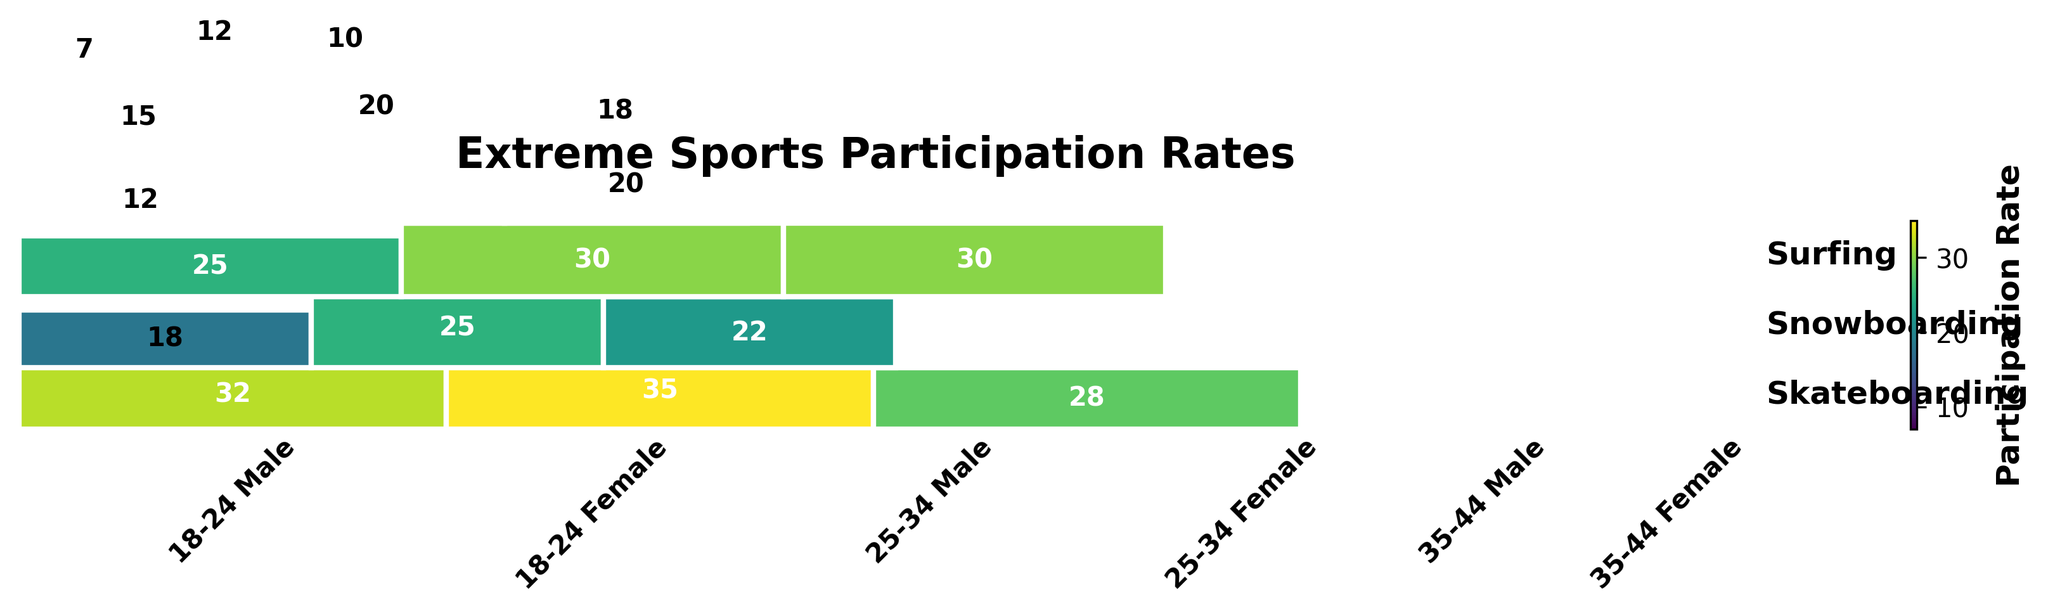Which age group and gender has the highest participation rate in skateboarding? By visually inspecting the plot, look for the rectangle representing the 18-24 age group and male gender under skateboarding. Compare this with other rectangles representing participation in skateboarding to identify which is the largest.
Answer: 18-24 Male What is the combined participation rate for 35-44 years old in all sports? Sum up the values for the 35-44 age group for both Male and Female across all sports. Add 15 (Skateboarding), 7 (Skateboarding), 18 (Surfing), 10 (Surfing), 20 (Snowboarding), and 12 (Snowboarding).
Answer: 82 Which sport shows the highest rate of participation for females aged 25-34? Look at the rectangles under the '25-34 Female' category and compare the heights for skateboarding, surfing, and snowboarding. The height with the largest value indicates the highest participation rate.
Answer: Snowboarding How does the participation rate of male snowboarders aged 25-34 compare to female snowboarders in the same age group? Find the rectangles corresponding to 25-34 Male Snowboarding and 25-34 Female Snowboarding. Compare their heights visually to see which one is higher or if they are equal.
Answer: Higher for Male What age group shows the most balanced gender participation in surfing? Look at the rectangles under the surfing category and compare the male and female participation rates within each age group. Balanced participation would have similar sized rectangles for both genders.
Answer: 18-24 What is the total participation in snowboarding across all age groups and genders? Sum the participation rates for snowboarding across all the rectangles representing different age groups and genders. Add 35 (18-24 Male), 25 (18-24 Female), 30 (25-34 Male), 22 (25-34 Female), 20 (35-44 Male), and 12 (35-44 Female).
Answer: 144 Which combination of age group and gender shows the lowest participation rate in any sport? Find and compare the smallest rectangles across all categories and identify which age group, gender, and sport it represents.
Answer: 35-44 Female Skateboarding Which sport has the highest regional disparity in participation rates between age groups? Compare the height differences across all age groups for each sport. The sport with the highest variation in rectangle heights indicates the most significant disparity.
Answer: Skateboarding What is the color indication representing the highest participation rate in the plot? Identify the color shading used in the plot and locate the rectangle with the darkest (or lightest, based on the color scheme) color, which indicates the highest participation rate.
Answer: Darkest (or lightest) color based on color scheme 